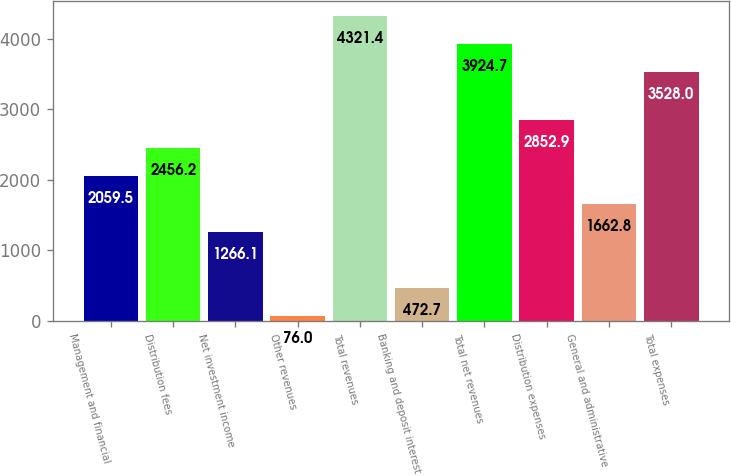Convert chart. <chart><loc_0><loc_0><loc_500><loc_500><bar_chart><fcel>Management and financial<fcel>Distribution fees<fcel>Net investment income<fcel>Other revenues<fcel>Total revenues<fcel>Banking and deposit interest<fcel>Total net revenues<fcel>Distribution expenses<fcel>General and administrative<fcel>Total expenses<nl><fcel>2059.5<fcel>2456.2<fcel>1266.1<fcel>76<fcel>4321.4<fcel>472.7<fcel>3924.7<fcel>2852.9<fcel>1662.8<fcel>3528<nl></chart> 